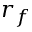<formula> <loc_0><loc_0><loc_500><loc_500>r _ { f }</formula> 